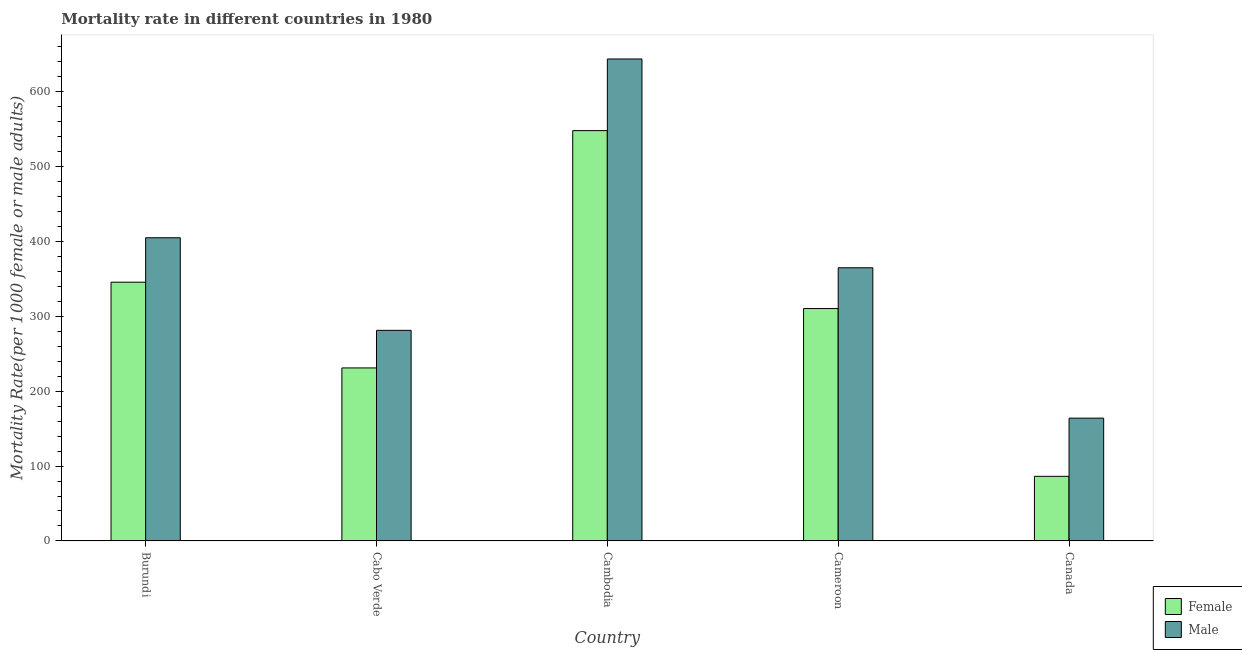How many different coloured bars are there?
Provide a short and direct response. 2. How many groups of bars are there?
Make the answer very short. 5. Are the number of bars per tick equal to the number of legend labels?
Your answer should be very brief. Yes. How many bars are there on the 5th tick from the left?
Give a very brief answer. 2. What is the label of the 2nd group of bars from the left?
Your answer should be very brief. Cabo Verde. What is the female mortality rate in Canada?
Keep it short and to the point. 86.32. Across all countries, what is the maximum male mortality rate?
Your answer should be compact. 643.85. Across all countries, what is the minimum female mortality rate?
Provide a short and direct response. 86.32. In which country was the male mortality rate maximum?
Provide a succinct answer. Cambodia. What is the total female mortality rate in the graph?
Offer a terse response. 1521.65. What is the difference between the female mortality rate in Burundi and that in Cameroon?
Your answer should be compact. 35.22. What is the difference between the female mortality rate in Burundi and the male mortality rate in Cabo Verde?
Your response must be concise. 64.33. What is the average male mortality rate per country?
Keep it short and to the point. 371.83. What is the difference between the female mortality rate and male mortality rate in Burundi?
Ensure brevity in your answer.  -59.35. What is the ratio of the female mortality rate in Cabo Verde to that in Canada?
Keep it short and to the point. 2.68. Is the female mortality rate in Cambodia less than that in Cameroon?
Provide a short and direct response. No. What is the difference between the highest and the second highest male mortality rate?
Ensure brevity in your answer.  238.85. What is the difference between the highest and the lowest female mortality rate?
Ensure brevity in your answer.  461.83. What does the 1st bar from the left in Burundi represents?
Keep it short and to the point. Female. What does the 2nd bar from the right in Cameroon represents?
Offer a very short reply. Female. What is the difference between two consecutive major ticks on the Y-axis?
Make the answer very short. 100. Does the graph contain grids?
Offer a very short reply. No. Where does the legend appear in the graph?
Offer a very short reply. Bottom right. How many legend labels are there?
Your answer should be very brief. 2. What is the title of the graph?
Ensure brevity in your answer.  Mortality rate in different countries in 1980. Does "Broad money growth" appear as one of the legend labels in the graph?
Offer a terse response. No. What is the label or title of the Y-axis?
Make the answer very short. Mortality Rate(per 1000 female or male adults). What is the Mortality Rate(per 1000 female or male adults) of Female in Burundi?
Make the answer very short. 345.65. What is the Mortality Rate(per 1000 female or male adults) of Male in Burundi?
Your answer should be compact. 405. What is the Mortality Rate(per 1000 female or male adults) in Female in Cabo Verde?
Make the answer very short. 231.1. What is the Mortality Rate(per 1000 female or male adults) in Male in Cabo Verde?
Give a very brief answer. 281.32. What is the Mortality Rate(per 1000 female or male adults) in Female in Cambodia?
Offer a very short reply. 548.15. What is the Mortality Rate(per 1000 female or male adults) of Male in Cambodia?
Offer a very short reply. 643.85. What is the Mortality Rate(per 1000 female or male adults) in Female in Cameroon?
Your answer should be compact. 310.43. What is the Mortality Rate(per 1000 female or male adults) in Male in Cameroon?
Offer a terse response. 364.92. What is the Mortality Rate(per 1000 female or male adults) in Female in Canada?
Make the answer very short. 86.32. What is the Mortality Rate(per 1000 female or male adults) in Male in Canada?
Your answer should be very brief. 164.05. Across all countries, what is the maximum Mortality Rate(per 1000 female or male adults) of Female?
Ensure brevity in your answer.  548.15. Across all countries, what is the maximum Mortality Rate(per 1000 female or male adults) of Male?
Your answer should be compact. 643.85. Across all countries, what is the minimum Mortality Rate(per 1000 female or male adults) in Female?
Offer a terse response. 86.32. Across all countries, what is the minimum Mortality Rate(per 1000 female or male adults) of Male?
Your response must be concise. 164.05. What is the total Mortality Rate(per 1000 female or male adults) of Female in the graph?
Your response must be concise. 1521.65. What is the total Mortality Rate(per 1000 female or male adults) of Male in the graph?
Offer a very short reply. 1859.14. What is the difference between the Mortality Rate(per 1000 female or male adults) of Female in Burundi and that in Cabo Verde?
Your answer should be very brief. 114.55. What is the difference between the Mortality Rate(per 1000 female or male adults) of Male in Burundi and that in Cabo Verde?
Your answer should be very brief. 123.68. What is the difference between the Mortality Rate(per 1000 female or male adults) of Female in Burundi and that in Cambodia?
Offer a very short reply. -202.49. What is the difference between the Mortality Rate(per 1000 female or male adults) in Male in Burundi and that in Cambodia?
Your answer should be very brief. -238.85. What is the difference between the Mortality Rate(per 1000 female or male adults) in Female in Burundi and that in Cameroon?
Your response must be concise. 35.22. What is the difference between the Mortality Rate(per 1000 female or male adults) of Male in Burundi and that in Cameroon?
Provide a short and direct response. 40.08. What is the difference between the Mortality Rate(per 1000 female or male adults) in Female in Burundi and that in Canada?
Your response must be concise. 259.34. What is the difference between the Mortality Rate(per 1000 female or male adults) in Male in Burundi and that in Canada?
Keep it short and to the point. 240.95. What is the difference between the Mortality Rate(per 1000 female or male adults) of Female in Cabo Verde and that in Cambodia?
Offer a very short reply. -317.05. What is the difference between the Mortality Rate(per 1000 female or male adults) in Male in Cabo Verde and that in Cambodia?
Provide a succinct answer. -362.53. What is the difference between the Mortality Rate(per 1000 female or male adults) of Female in Cabo Verde and that in Cameroon?
Make the answer very short. -79.33. What is the difference between the Mortality Rate(per 1000 female or male adults) of Male in Cabo Verde and that in Cameroon?
Provide a succinct answer. -83.61. What is the difference between the Mortality Rate(per 1000 female or male adults) of Female in Cabo Verde and that in Canada?
Your answer should be very brief. 144.79. What is the difference between the Mortality Rate(per 1000 female or male adults) in Male in Cabo Verde and that in Canada?
Your response must be concise. 117.27. What is the difference between the Mortality Rate(per 1000 female or male adults) of Female in Cambodia and that in Cameroon?
Ensure brevity in your answer.  237.72. What is the difference between the Mortality Rate(per 1000 female or male adults) in Male in Cambodia and that in Cameroon?
Provide a succinct answer. 278.93. What is the difference between the Mortality Rate(per 1000 female or male adults) in Female in Cambodia and that in Canada?
Provide a short and direct response. 461.83. What is the difference between the Mortality Rate(per 1000 female or male adults) of Male in Cambodia and that in Canada?
Provide a short and direct response. 479.81. What is the difference between the Mortality Rate(per 1000 female or male adults) of Female in Cameroon and that in Canada?
Ensure brevity in your answer.  224.12. What is the difference between the Mortality Rate(per 1000 female or male adults) in Male in Cameroon and that in Canada?
Provide a succinct answer. 200.88. What is the difference between the Mortality Rate(per 1000 female or male adults) of Female in Burundi and the Mortality Rate(per 1000 female or male adults) of Male in Cabo Verde?
Provide a succinct answer. 64.33. What is the difference between the Mortality Rate(per 1000 female or male adults) of Female in Burundi and the Mortality Rate(per 1000 female or male adults) of Male in Cambodia?
Provide a short and direct response. -298.2. What is the difference between the Mortality Rate(per 1000 female or male adults) of Female in Burundi and the Mortality Rate(per 1000 female or male adults) of Male in Cameroon?
Offer a very short reply. -19.27. What is the difference between the Mortality Rate(per 1000 female or male adults) in Female in Burundi and the Mortality Rate(per 1000 female or male adults) in Male in Canada?
Give a very brief answer. 181.61. What is the difference between the Mortality Rate(per 1000 female or male adults) of Female in Cabo Verde and the Mortality Rate(per 1000 female or male adults) of Male in Cambodia?
Ensure brevity in your answer.  -412.75. What is the difference between the Mortality Rate(per 1000 female or male adults) in Female in Cabo Verde and the Mortality Rate(per 1000 female or male adults) in Male in Cameroon?
Give a very brief answer. -133.82. What is the difference between the Mortality Rate(per 1000 female or male adults) of Female in Cabo Verde and the Mortality Rate(per 1000 female or male adults) of Male in Canada?
Give a very brief answer. 67.06. What is the difference between the Mortality Rate(per 1000 female or male adults) in Female in Cambodia and the Mortality Rate(per 1000 female or male adults) in Male in Cameroon?
Your response must be concise. 183.22. What is the difference between the Mortality Rate(per 1000 female or male adults) in Female in Cambodia and the Mortality Rate(per 1000 female or male adults) in Male in Canada?
Your response must be concise. 384.1. What is the difference between the Mortality Rate(per 1000 female or male adults) of Female in Cameroon and the Mortality Rate(per 1000 female or male adults) of Male in Canada?
Make the answer very short. 146.38. What is the average Mortality Rate(per 1000 female or male adults) of Female per country?
Make the answer very short. 304.33. What is the average Mortality Rate(per 1000 female or male adults) of Male per country?
Your answer should be very brief. 371.83. What is the difference between the Mortality Rate(per 1000 female or male adults) of Female and Mortality Rate(per 1000 female or male adults) of Male in Burundi?
Offer a very short reply. -59.34. What is the difference between the Mortality Rate(per 1000 female or male adults) of Female and Mortality Rate(per 1000 female or male adults) of Male in Cabo Verde?
Keep it short and to the point. -50.22. What is the difference between the Mortality Rate(per 1000 female or male adults) of Female and Mortality Rate(per 1000 female or male adults) of Male in Cambodia?
Offer a very short reply. -95.7. What is the difference between the Mortality Rate(per 1000 female or male adults) of Female and Mortality Rate(per 1000 female or male adults) of Male in Cameroon?
Your answer should be very brief. -54.49. What is the difference between the Mortality Rate(per 1000 female or male adults) in Female and Mortality Rate(per 1000 female or male adults) in Male in Canada?
Make the answer very short. -77.73. What is the ratio of the Mortality Rate(per 1000 female or male adults) in Female in Burundi to that in Cabo Verde?
Your answer should be compact. 1.5. What is the ratio of the Mortality Rate(per 1000 female or male adults) of Male in Burundi to that in Cabo Verde?
Ensure brevity in your answer.  1.44. What is the ratio of the Mortality Rate(per 1000 female or male adults) in Female in Burundi to that in Cambodia?
Provide a succinct answer. 0.63. What is the ratio of the Mortality Rate(per 1000 female or male adults) in Male in Burundi to that in Cambodia?
Ensure brevity in your answer.  0.63. What is the ratio of the Mortality Rate(per 1000 female or male adults) in Female in Burundi to that in Cameroon?
Your response must be concise. 1.11. What is the ratio of the Mortality Rate(per 1000 female or male adults) of Male in Burundi to that in Cameroon?
Ensure brevity in your answer.  1.11. What is the ratio of the Mortality Rate(per 1000 female or male adults) of Female in Burundi to that in Canada?
Your response must be concise. 4. What is the ratio of the Mortality Rate(per 1000 female or male adults) of Male in Burundi to that in Canada?
Offer a terse response. 2.47. What is the ratio of the Mortality Rate(per 1000 female or male adults) in Female in Cabo Verde to that in Cambodia?
Your response must be concise. 0.42. What is the ratio of the Mortality Rate(per 1000 female or male adults) in Male in Cabo Verde to that in Cambodia?
Offer a terse response. 0.44. What is the ratio of the Mortality Rate(per 1000 female or male adults) of Female in Cabo Verde to that in Cameroon?
Provide a succinct answer. 0.74. What is the ratio of the Mortality Rate(per 1000 female or male adults) in Male in Cabo Verde to that in Cameroon?
Provide a succinct answer. 0.77. What is the ratio of the Mortality Rate(per 1000 female or male adults) of Female in Cabo Verde to that in Canada?
Your answer should be compact. 2.68. What is the ratio of the Mortality Rate(per 1000 female or male adults) of Male in Cabo Verde to that in Canada?
Offer a very short reply. 1.71. What is the ratio of the Mortality Rate(per 1000 female or male adults) of Female in Cambodia to that in Cameroon?
Offer a very short reply. 1.77. What is the ratio of the Mortality Rate(per 1000 female or male adults) in Male in Cambodia to that in Cameroon?
Your response must be concise. 1.76. What is the ratio of the Mortality Rate(per 1000 female or male adults) in Female in Cambodia to that in Canada?
Your answer should be very brief. 6.35. What is the ratio of the Mortality Rate(per 1000 female or male adults) of Male in Cambodia to that in Canada?
Make the answer very short. 3.92. What is the ratio of the Mortality Rate(per 1000 female or male adults) in Female in Cameroon to that in Canada?
Your answer should be compact. 3.6. What is the ratio of the Mortality Rate(per 1000 female or male adults) in Male in Cameroon to that in Canada?
Provide a succinct answer. 2.22. What is the difference between the highest and the second highest Mortality Rate(per 1000 female or male adults) in Female?
Your answer should be very brief. 202.49. What is the difference between the highest and the second highest Mortality Rate(per 1000 female or male adults) in Male?
Your answer should be very brief. 238.85. What is the difference between the highest and the lowest Mortality Rate(per 1000 female or male adults) in Female?
Make the answer very short. 461.83. What is the difference between the highest and the lowest Mortality Rate(per 1000 female or male adults) in Male?
Offer a terse response. 479.81. 